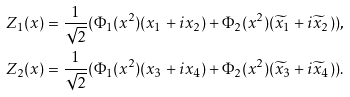Convert formula to latex. <formula><loc_0><loc_0><loc_500><loc_500>Z _ { 1 } ( x ) = \frac { 1 } { \sqrt { 2 } } ( \Phi _ { 1 } ( x ^ { 2 } ) ( x _ { 1 } + i x _ { 2 } ) + \Phi _ { 2 } ( x ^ { 2 } ) ( \widetilde { x } _ { 1 } + i \widetilde { x } _ { 2 } ) ) , \\ Z _ { 2 } ( x ) = \frac { 1 } { \sqrt { 2 } } ( \Phi _ { 1 } ( x ^ { 2 } ) ( x _ { 3 } + i x _ { 4 } ) + \Phi _ { 2 } ( x ^ { 2 } ) ( \widetilde { x } _ { 3 } + i \widetilde { x } _ { 4 } ) ) .</formula> 